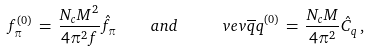Convert formula to latex. <formula><loc_0><loc_0><loc_500><loc_500>f _ { \pi } ^ { ( 0 ) } \, = \, \frac { N _ { c } M ^ { 2 } } { 4 \pi ^ { 2 } f } \hat { f } _ { \pi } \quad a n d \quad \ v e v { \overline { q } q } ^ { ( 0 ) } \, = \, \frac { N _ { c } M } { 4 \pi ^ { 2 } } \hat { C } _ { q } \, ,</formula> 